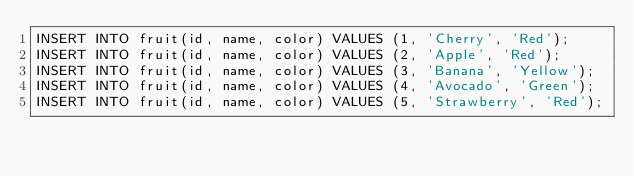<code> <loc_0><loc_0><loc_500><loc_500><_SQL_>INSERT INTO fruit(id, name, color) VALUES (1, 'Cherry', 'Red');
INSERT INTO fruit(id, name, color) VALUES (2, 'Apple', 'Red');
INSERT INTO fruit(id, name, color) VALUES (3, 'Banana', 'Yellow');
INSERT INTO fruit(id, name, color) VALUES (4, 'Avocado', 'Green');
INSERT INTO fruit(id, name, color) VALUES (5, 'Strawberry', 'Red');
</code> 